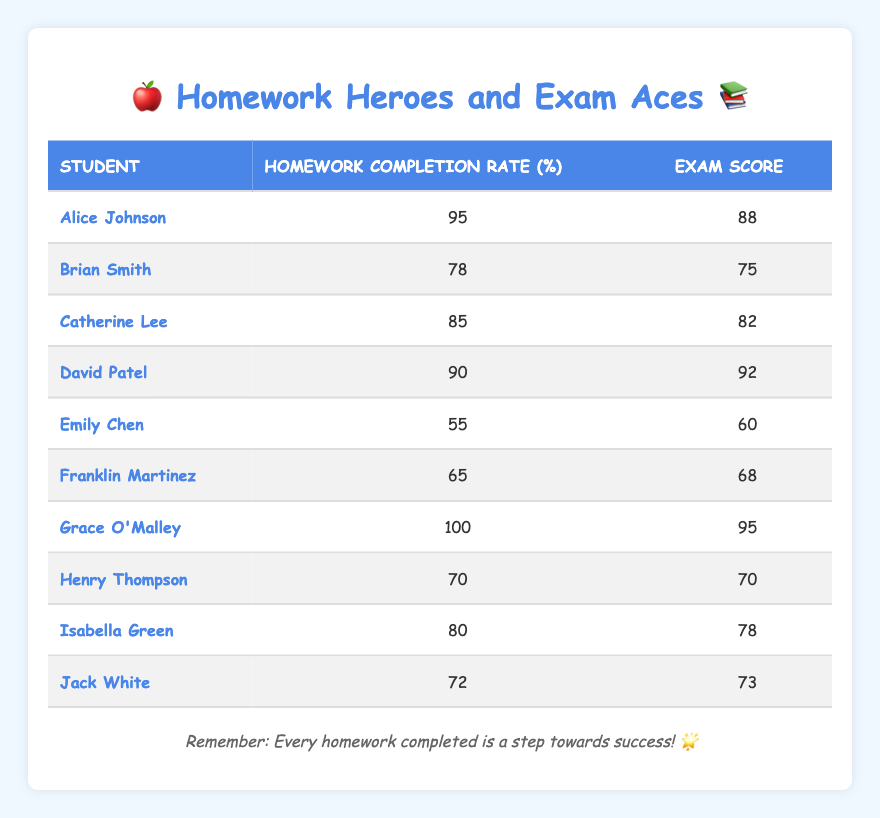What is the homework completion rate of Grace O'Malley? From the table, looking at Grace O'Malley's row, her Homework Completion Rate is 100%.
Answer: 100 Who scored the highest on the exam? By checking the Exam Score column, David Patel has the highest score of 92.
Answer: David Patel What is the average homework completion rate of all students? To calculate the average, add all the Homework Completion Rates: 95 + 78 + 85 + 90 + 55 + 65 + 100 + 70 + 80 + 72 = 790, then divide by the number of students, which is 10. So, 790 / 10 = 79.
Answer: 79 Is there any student who completed 100% of their homework? Checking the Homework Completion Rate column, Grace O'Malley is the only student with a completion rate of 100%.
Answer: Yes What is the difference between the highest and lowest exam scores? The highest score is 92 (David Patel) and the lowest is 60 (Emily Chen). Calculate the difference: 92 - 60 = 32.
Answer: 32 Which student has the lowest exam score, and what is that score? Looking through the Exam Score column, Emily Chen has the lowest score of 60.
Answer: Emily Chen, 60 How many students scored more than 80 on their exams? By reviewing the Exam Score column, the students with scores greater than 80 are Alice Johnson (88), Catherine Lee (82), David Patel (92), and Grace O'Malley (95). That's a total of 4 students.
Answer: 4 What is the median homework completion rate among all students? To find the median, list the Homework Completion Rates in ascending order: 55, 65, 70, 72, 78, 80, 85, 90, 95, 100. Since there are 10 values, the median will be the average of the 5th and 6th values: (78 + 80) / 2 = 79.
Answer: 79 Which student had a homework completion rate of 72%? Looking for the 72% in the Homework Completion Rate section, Jack White is the student with that rate.
Answer: Jack White 